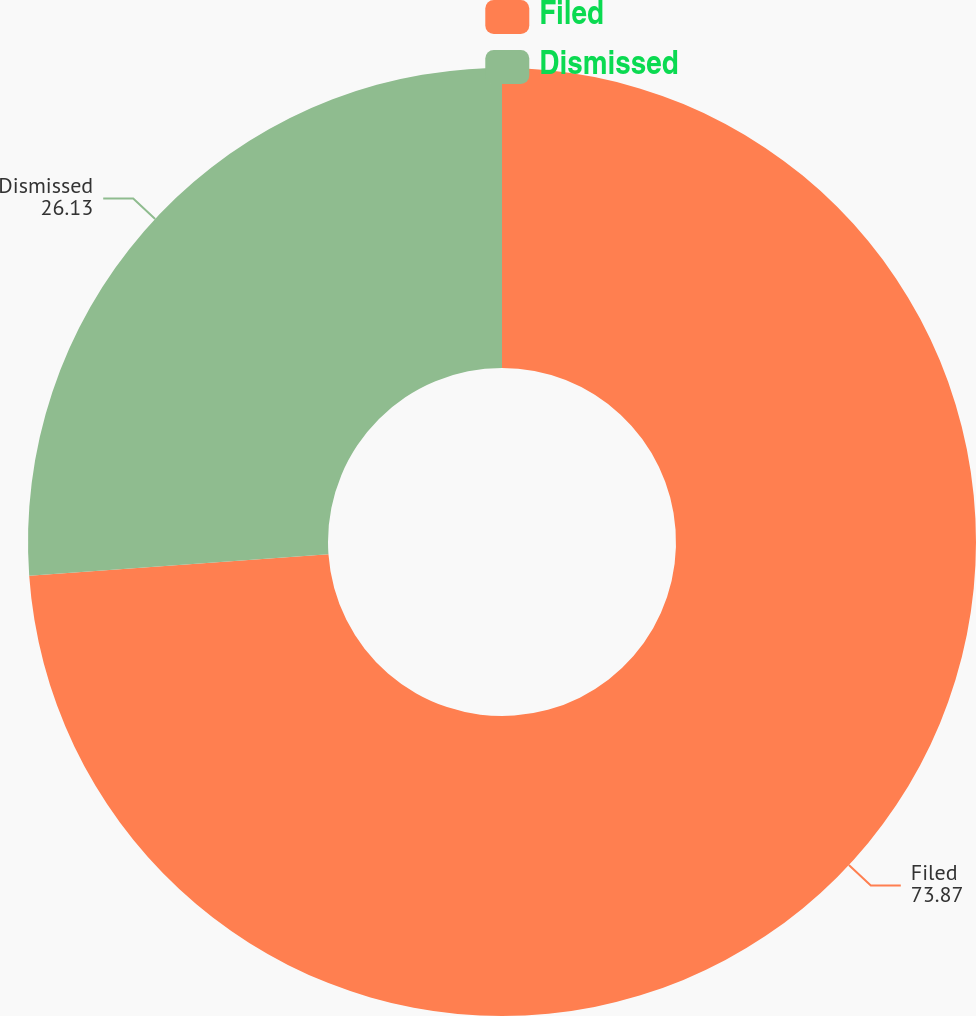Convert chart. <chart><loc_0><loc_0><loc_500><loc_500><pie_chart><fcel>Filed<fcel>Dismissed<nl><fcel>73.87%<fcel>26.13%<nl></chart> 